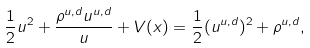<formula> <loc_0><loc_0><loc_500><loc_500>\frac { 1 } { 2 } u ^ { 2 } + \frac { \rho ^ { u , d } u ^ { u , d } } u + V ( x ) = \frac { 1 } { 2 } ( u ^ { u , d } ) ^ { 2 } + \rho ^ { u , d } ,</formula> 